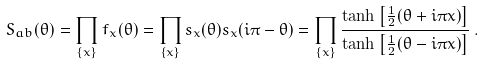<formula> <loc_0><loc_0><loc_500><loc_500>S _ { a b } ( \theta ) = \prod _ { \left \{ x \right \} } f _ { x } ( \theta ) = \prod _ { \left \{ x \right \} } s _ { x } ( \theta ) s _ { x } ( i \pi - \theta ) = \prod _ { \left \{ x \right \} } \frac { \tanh \left [ \frac { 1 } { 2 } ( \theta + i \pi x ) \right ] } { \tanh \left [ \frac { 1 } { 2 } ( \theta - i \pi x ) \right ] } \, .</formula> 